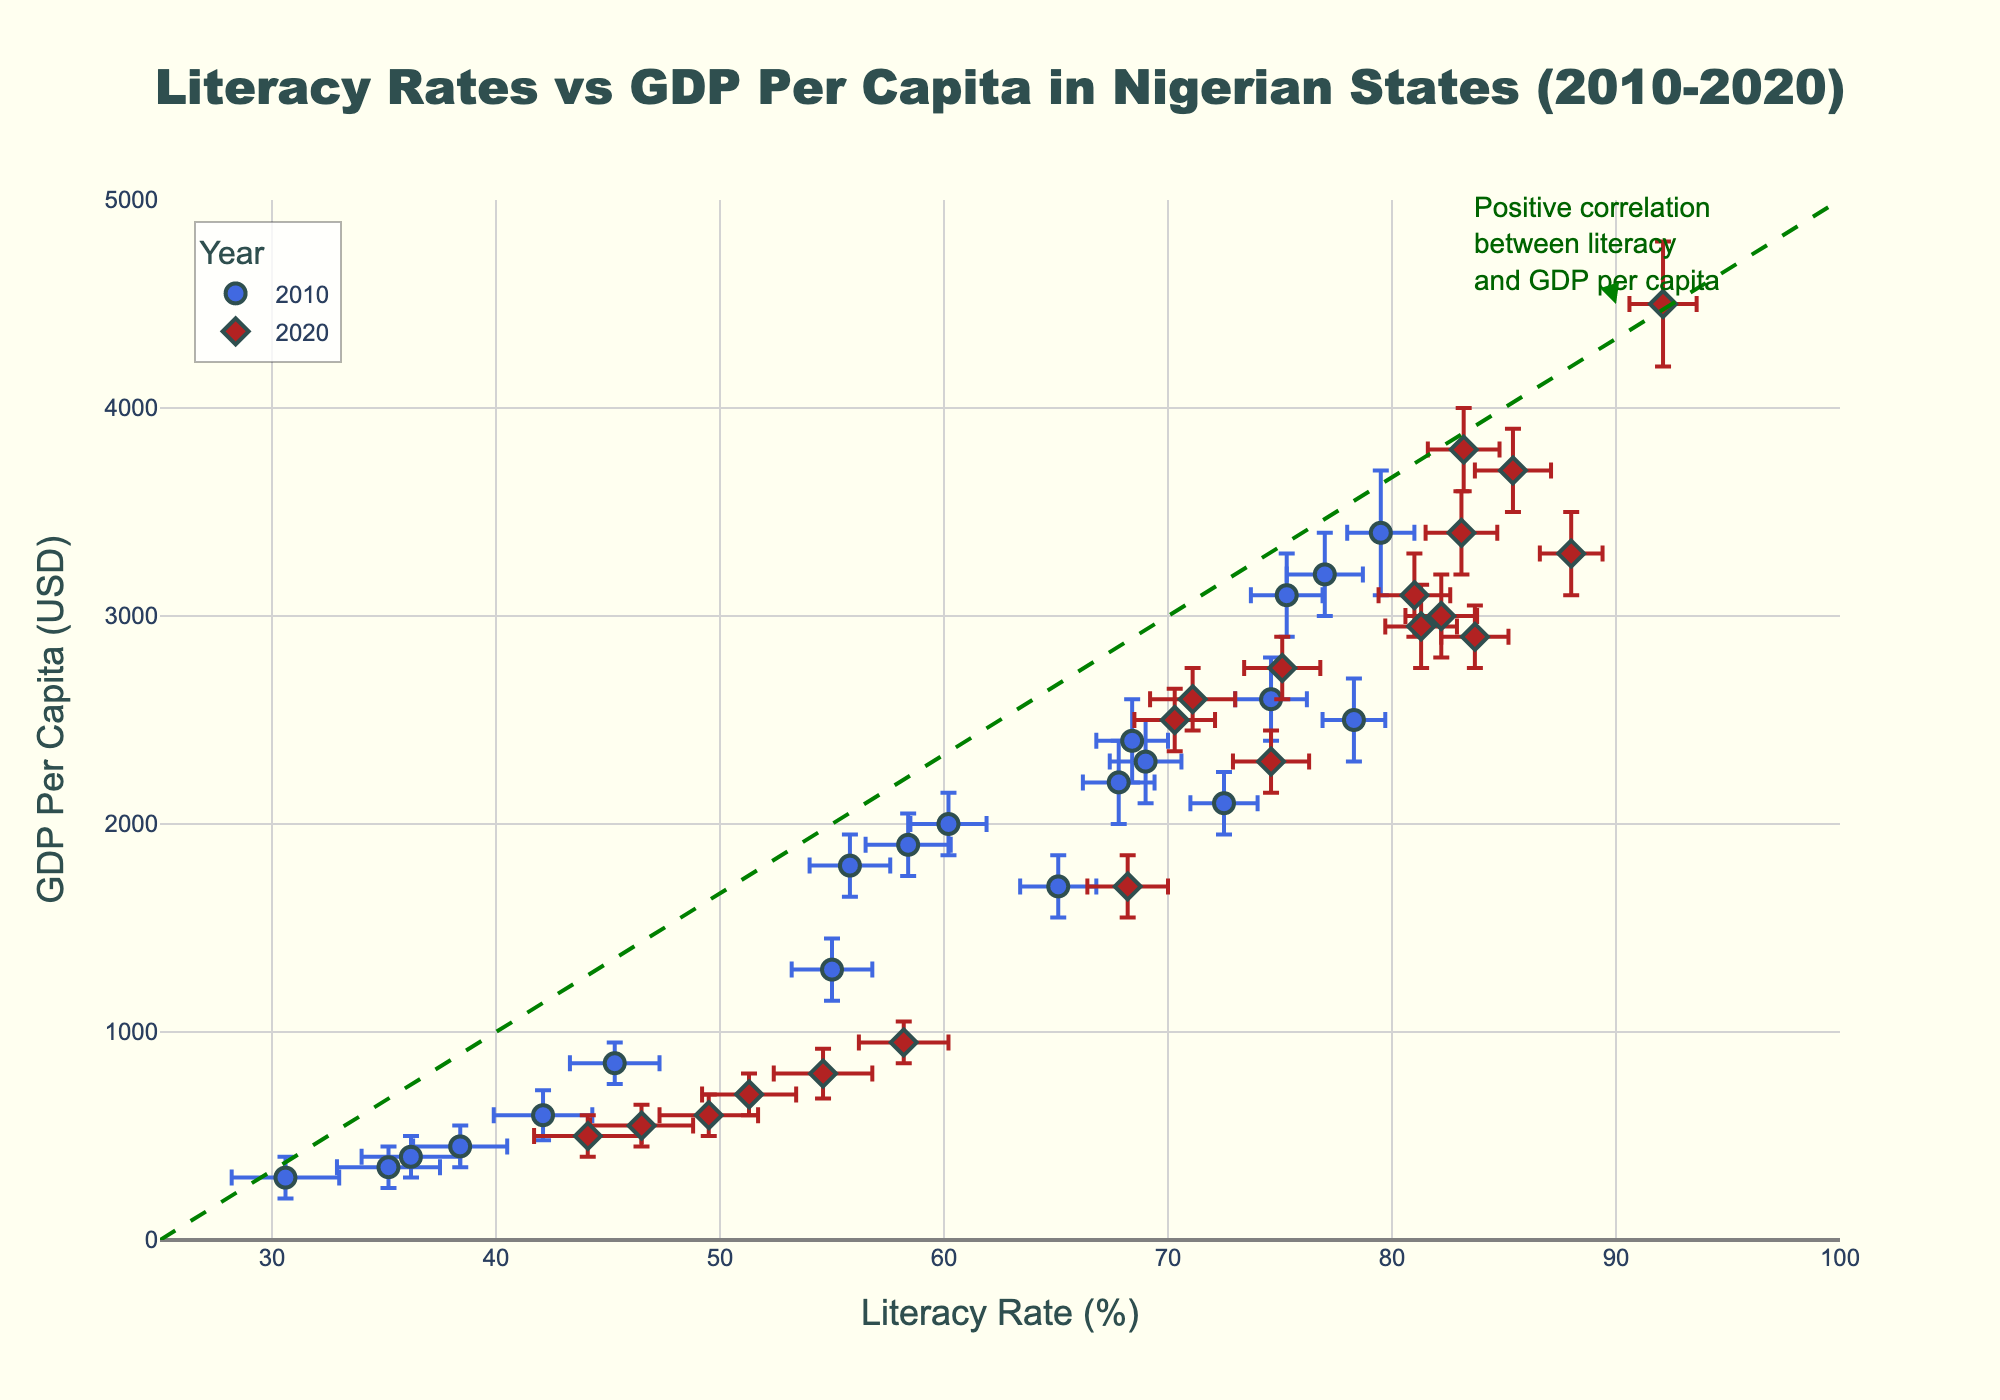What does the figure title indicate? The title says "Literacy Rates vs GDP Per Capita in Nigerian States (2010-2020)", which indicates that the figure is a scatter plot showing the relationship between literacy rates and GDP per capita for different Nigerian states over two years, 2010 and 2020.
Answer: The title indicates the relationship between literacy rates and GDP per capita in Nigerian states from 2010 to 2020 What colors represent the years 2010 and 2020? The legend in the figure shows that data points for 2010 are colored royal blue, while data points for 2020 are colored firebrick.
Answer: 2010 is royal blue and 2020 is firebrick Which state had the highest literacy rate in 2020? By examining the x-axis for 2020 data points (firebrick color and diamond symbol), the highest literacy rate is around 92.1%, which corresponds to Lagos.
Answer: Lagos What is the GDP per capita of Kano in 2020? Locate Kano's data point marked by the firebrick color for 2020, then check the y-axis value. Kano's GDP per capita in 2020 is 950 USD.
Answer: 950 USD How did the literacy rate and GDP per capita of Lagos change from 2010 to 2020? For Lagos, compare the literacy rate from 79.5% in 2010 to 92.1% in 2020 and GDP per capita from 3400 USD in 2010 to 4500 USD in 2020. Both metrics increased.
Answer: Increased Which state had the largest error in literacy rate in 2020? The largest error bar in literacy rate for 2020 can be found by observing the longest horizontal error bar among the firebrick colored data points, which belongs to Sokoto with an error of 2.4%.
Answer: Sokoto What is the positive correlation in the plot indicated by the annotation? The annotation points out the observable trend that states with higher literacy rates tend to have higher GDP per capita, as evidenced by the data points aligning with the dashed green diagonal line suggesting this positive correlation.
Answer: Higher literacy rates are associated with higher GDP per capita Which state had the smallest increase in GDP per capita between 2010 and 2020? Calculate the difference in GDP per capita for each state. Jigawa had the smallest increase, from 450 USD in 2010 to 700 USD in 2020, an increase of 250 USD.
Answer: Jigawa How does the GDP per capita of Borno in 2020 compare with its GDP per capita in 2010? For Borno, examine its data points: GDP per capita from 350 USD in 2010 increased to 550 USD in 2020.
Answer: Increased What is the approximate trendline suggested by the dashed green line? The green dashed line implies a positive linear relationship, where GDP per capita increases as literacy rates increase. This trendline infers that higher literacy rates likely lead to higher economic output per capita.
Answer: Positive linear relationship 